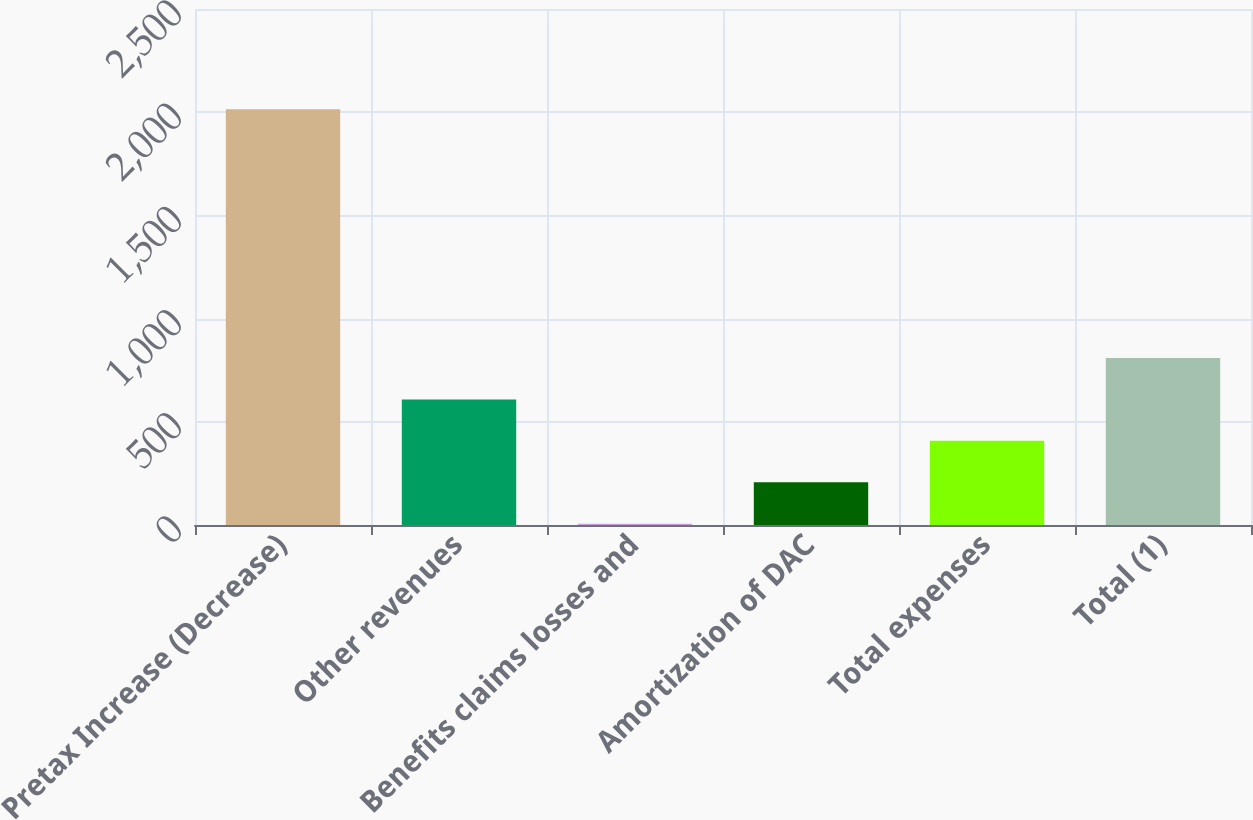<chart> <loc_0><loc_0><loc_500><loc_500><bar_chart><fcel>Pretax Increase (Decrease)<fcel>Other revenues<fcel>Benefits claims losses and<fcel>Amortization of DAC<fcel>Total expenses<fcel>Total (1)<nl><fcel>2014<fcel>608.4<fcel>6<fcel>206.8<fcel>407.6<fcel>809.2<nl></chart> 